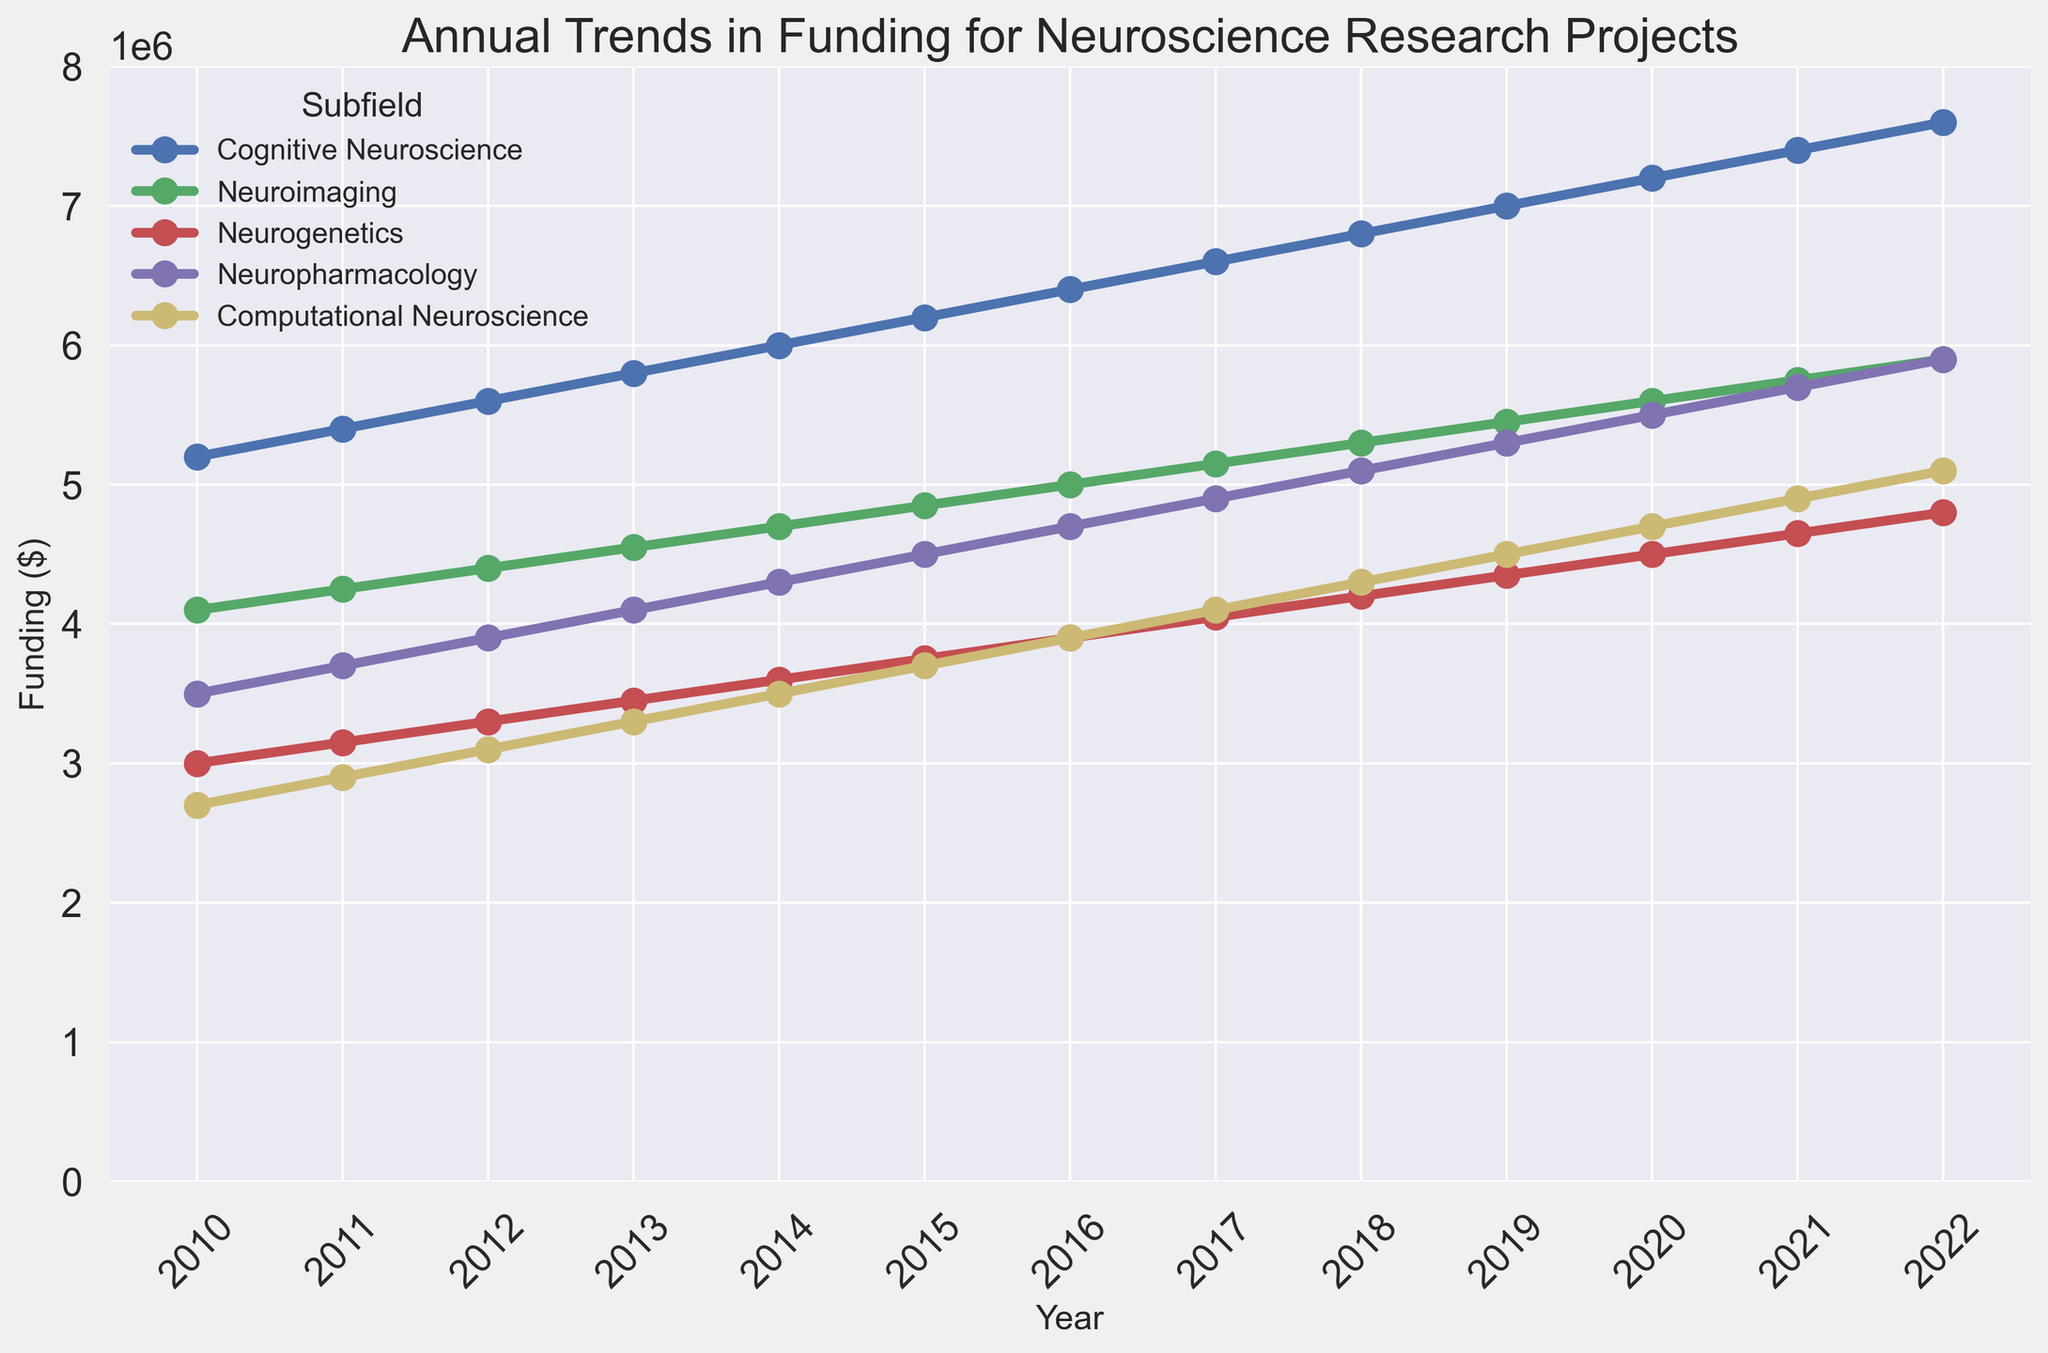Which subfield had the highest funding in 2022? To find this, locate the data points for each subfield on the rightmost side of the plot for the year 2022. Identify the line with the highest y-value.
Answer: Cognitive Neuroscience How did the funding for Computational Neuroscience change from 2010 to 2022? Identify the data points corresponding to "Computational Neuroscience" in 2010 and 2022, and subtract the former from the latter: 5100000 - 2700000.
Answer: Increased by $2,400,000 Which subfield experienced the least increase in funding from 2010 to 2022? Calculate the funding increase for each subfield from 2010 to 2022 and compare: 
- Cognitive Neuroscience: 7600000 - 5200000 = 2400000
- Neuroimaging: 5900000 - 4100000 = 1800000
- Neurogenetics: 4800000 - 3000000 = 1800000
- Neuropharmacology: 5900000 - 3500000 = 2400000
- Computational Neuroscience: 5100000 - 2700000 = 2400000
The minimal increase is shared by Neuroimaging and Neurogenetics.
Answer: Neuroimaging and Neurogenetics In which year did Cognitive Neuroscience funding cross $6,000,000? Observe the trend line for "Cognitive Neuroscience" and pinpoint the year at which the y-value first exceeds $6,000,000.
Answer: 2014 Compare the funding for Neuroimaging and Neuropharmacology in 2015. Which was higher? Focus on the data points for Neuroimaging and Neuropharmacology in 2015 and compare their y-values.
Answer: Neuroimaging Was the funding trend for any subfield flat between any consecutive years? Examine each line on the plot for any segments that are horizontal, indicating no change in funding. Each year shows an increase, meaning no subfield had flat funding between consecutive years.
Answer: No What was the average annual funding for Neurogenetics over the period from 2010 to 2022? Sum the funding values for Neurogenetics from 2010 to 2022 and divide by the number of years: (3000000 + 3150000 + 3300000 + 3450000 + 3600000 + 3750000 + 3900000 + 4050000 + 4200000 + 4350000 + 4500000 + 4650000 + 4800000) / 13.
Answer: $3,750,000 Was there any year when Neuroimaging funding decreased compared to the previous year? Track the trend line for Neuroimaging and check for any dips compared to the prior year. Each year shows an increase, so no funding decreases are present across the specified years.
Answer: No Which two subfields had the closest funding in 2020? Look at the data points for each subfield in 2020 and identify the ones with the most similar y-values. Compare:
- Cognitive Neuroscience: 7200000
- Neuroimaging: 5600000
- Neurogenetics: 4500000
- Neuropharmacology: 5500000
- Computational Neuroscience: 4700000
Neuroimaging and Neuropharmacology funding are closest.
Answer: Neuroimaging and Neuropharmacology 